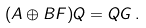Convert formula to latex. <formula><loc_0><loc_0><loc_500><loc_500>( A \oplus B F ) Q = Q G \, .</formula> 